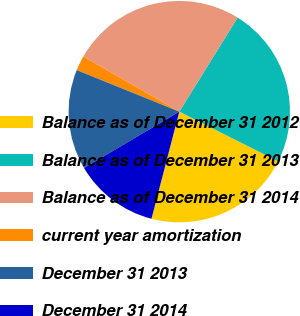<chart> <loc_0><loc_0><loc_500><loc_500><pie_chart><fcel>Balance as of December 31 2012<fcel>Balance as of December 31 2013<fcel>Balance as of December 31 2014<fcel>current year amortization<fcel>December 31 2013<fcel>December 31 2014<nl><fcel>21.63%<fcel>23.58%<fcel>25.53%<fcel>2.18%<fcel>14.63%<fcel>12.45%<nl></chart> 